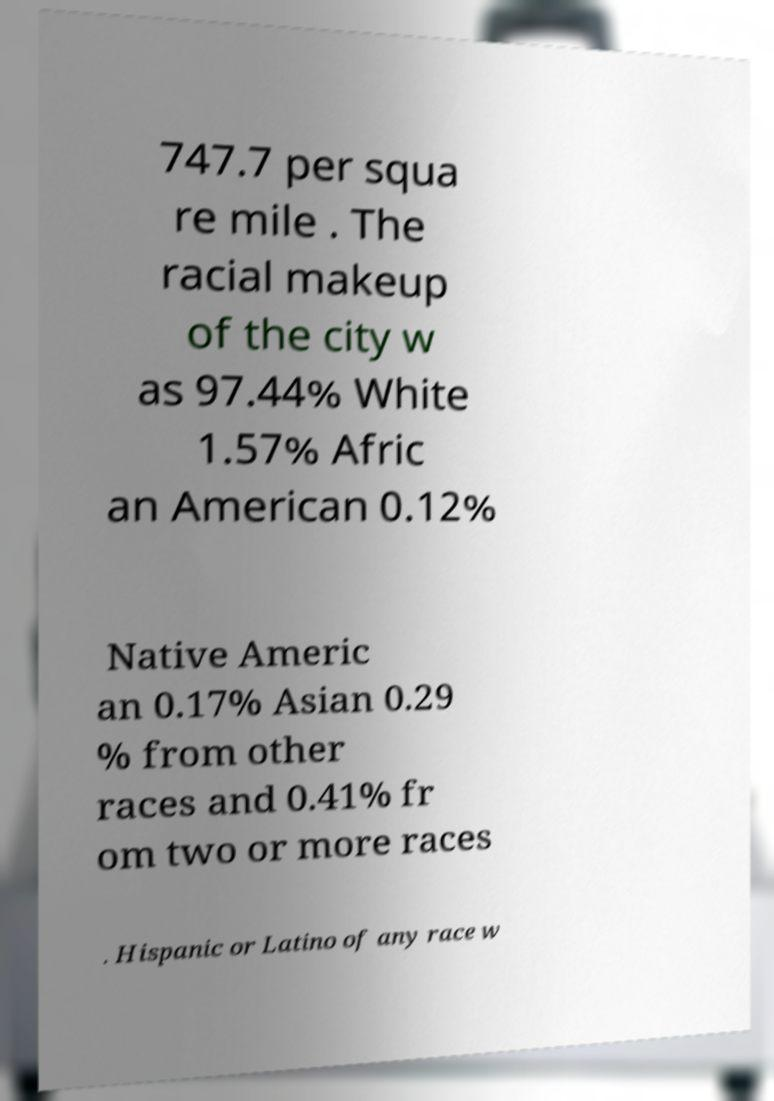For documentation purposes, I need the text within this image transcribed. Could you provide that? 747.7 per squa re mile . The racial makeup of the city w as 97.44% White 1.57% Afric an American 0.12% Native Americ an 0.17% Asian 0.29 % from other races and 0.41% fr om two or more races . Hispanic or Latino of any race w 